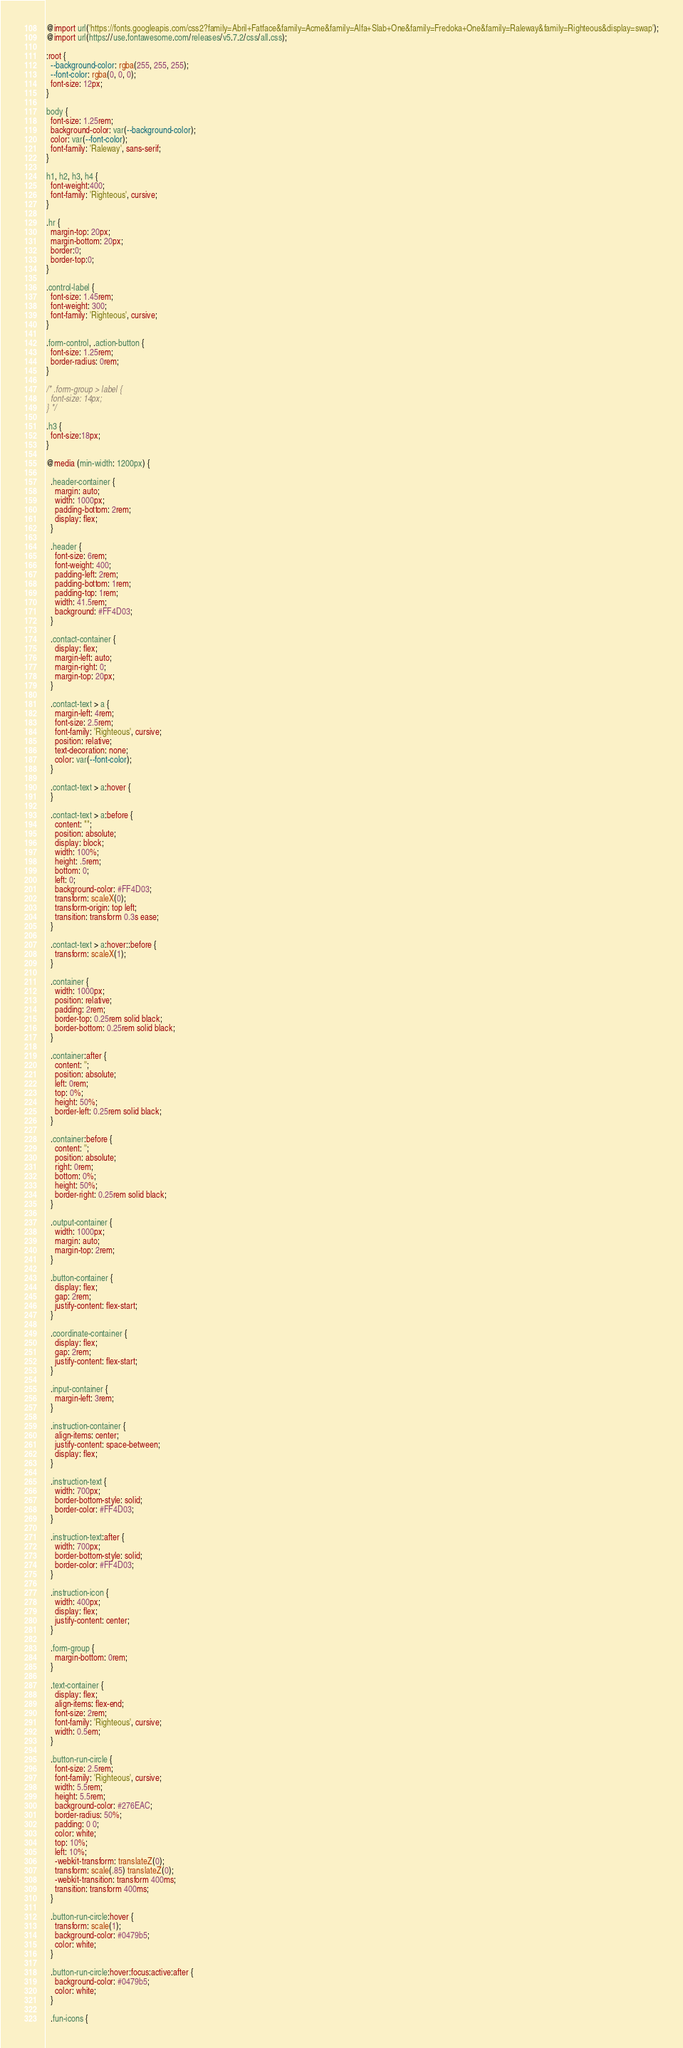Convert code to text. <code><loc_0><loc_0><loc_500><loc_500><_CSS_>@import url('https://fonts.googleapis.com/css2?family=Abril+Fatface&family=Acme&family=Alfa+Slab+One&family=Fredoka+One&family=Raleway&family=Righteous&display=swap');
@import url(https://use.fontawesome.com/releases/v5.7.2/css/all.css);

:root {
  --background-color: rgba(255, 255, 255);
  --font-color: rgba(0, 0, 0);
  font-size: 12px;
}

body {
  font-size: 1.25rem;
  background-color: var(--background-color);
  color: var(--font-color);
  font-family: 'Raleway', sans-serif;
}

h1, h2, h3, h4 {
  font-weight:400;
  font-family: 'Righteous', cursive;
}

.hr {
  margin-top: 20px;
  margin-bottom: 20px;
  border:0;
  border-top:0;
}

.control-label {
  font-size: 1.45rem;
  font-weight: 300;
  font-family: 'Righteous', cursive;
}

.form-control, .action-button {
  font-size: 1.25rem;
  border-radius: 0rem;
}

/* .form-group > label {
  font-size: 14px;
} */

.h3 {
  font-size:18px;
}

@media (min-width: 1200px) {

  .header-container {
    margin: auto;
    width: 1000px;
    padding-bottom: 2rem;
    display: flex;
  }

  .header {
    font-size: 6rem;
    font-weight: 400;
    padding-left: 2rem;
    padding-bottom: 1rem;
    padding-top: 1rem;
    width: 41.5rem;
    background: #FF4D03;
  }

  .contact-container {
    display: flex;
    margin-left: auto; 
    margin-right: 0;
    margin-top: 20px;
  }

  .contact-text > a {
    margin-left: 4rem;
    font-size: 2.5rem;
    font-family: 'Righteous', cursive;
    position: relative;
    text-decoration: none;
    color: var(--font-color);
  }

  .contact-text > a:hover {
  }

  .contact-text > a:before {
    content: "";
    position: absolute;
    display: block;
    width: 100%;
    height: .5rem;
    bottom: 0;
    left: 0;
    background-color: #FF4D03;
    transform: scaleX(0);
    transform-origin: top left;
    transition: transform 0.3s ease;
  }

  .contact-text > a:hover::before {
    transform: scaleX(1);
  }

  .container {
    width: 1000px;
    position: relative;
    padding: 2rem;
    border-top: 0.25rem solid black;
    border-bottom: 0.25rem solid black;
  }

  .container:after {
    content: '';
    position: absolute;
    left: 0rem;
    top: 0%;
    height: 50%;
    border-left: 0.25rem solid black;
  }

  .container:before {
    content: '';
    position: absolute;
    right: 0rem;
    bottom: 0%;
    height: 50%;
    border-right: 0.25rem solid black;
  }

  .output-container {
    width: 1000px;
    margin: auto;
    margin-top: 2rem;
  }

  .button-container {
    display: flex;
    gap: 2rem;
    justify-content: flex-start;
  }

  .coordinate-container {
    display: flex;
    gap: 2rem;
    justify-content: flex-start;
  }

  .input-container {
    margin-left: 3rem;
  }

  .instruction-container {
    align-items: center;
    justify-content: space-between;
    display: flex;
  }

  .instruction-text {
    width: 700px;
    border-bottom-style: solid;
    border-color: #FF4D03;
  }

  .instruction-text:after {
    width: 700px;
    border-bottom-style: solid;
    border-color: #FF4D03;
  }

  .instruction-icon {
    width: 400px;
    display: flex;
    justify-content: center;
  }

  .form-group {
    margin-bottom: 0rem;
  }

  .text-container {
    display: flex;
    align-items: flex-end;
    font-size: 2rem;
    font-family: 'Righteous', cursive;
    width: 0.5em;
  }

  .button-run-circle {
    font-size: 2.5rem;
    font-family: 'Righteous', cursive;
    width: 5.5rem;
    height: 5.5rem;
    background-color: #276EAC;
    border-radius: 50%;
    padding: 0 0;
    color: white;
    top: 10%;
    left: 10%;
    -webkit-transform: translateZ(0);
    transform: scale(.85) translateZ(0);
    -webkit-transition: transform 400ms;
    transition: transform 400ms;
  }

  .button-run-circle:hover {
    transform: scale(1);
    background-color: #0479b5;
    color: white;
  }

  .button-run-circle:hover:focus:active:after {
    background-color: #0479b5;
    color: white;
  }

  .fun-icons {</code> 